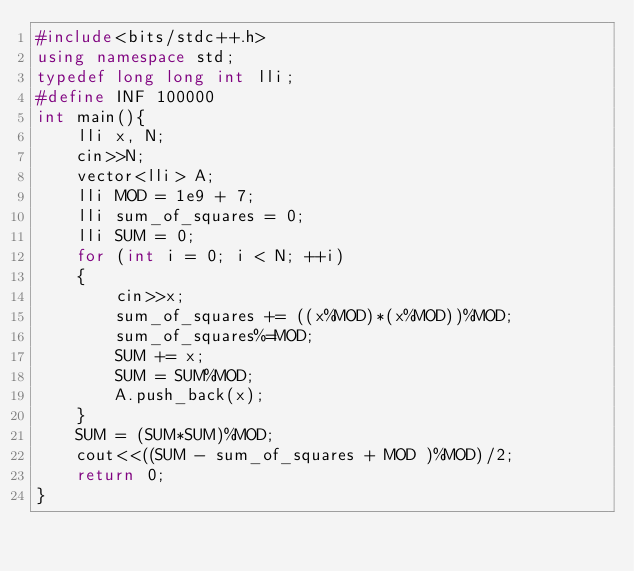Convert code to text. <code><loc_0><loc_0><loc_500><loc_500><_C++_>#include<bits/stdc++.h>
using namespace std;
typedef long long int lli;
#define INF 100000
int main(){
	lli x, N;
	cin>>N;
	vector<lli> A;
	lli MOD = 1e9 + 7;
	lli sum_of_squares = 0;
	lli SUM = 0;
	for (int i = 0; i < N; ++i)
	{
		cin>>x;
		sum_of_squares += ((x%MOD)*(x%MOD))%MOD;
		sum_of_squares%=MOD;
		SUM += x;
		SUM = SUM%MOD;
		A.push_back(x);
	}
	SUM = (SUM*SUM)%MOD;
	cout<<((SUM - sum_of_squares + MOD )%MOD)/2;
	return 0;
}</code> 